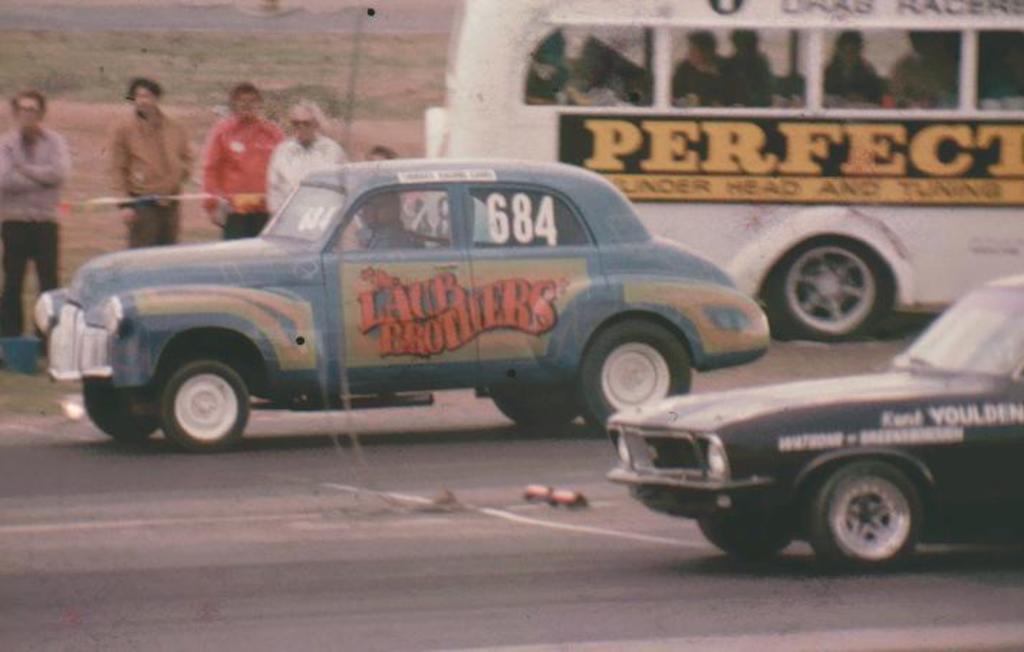In one or two sentences, can you explain what this image depicts? This picture is clicked outside the city. We see black and blue car moving on the road. Behind that, we see a white bus which is moving on the road. Behind the car, we see four people standing. Behind that, we see grass. 